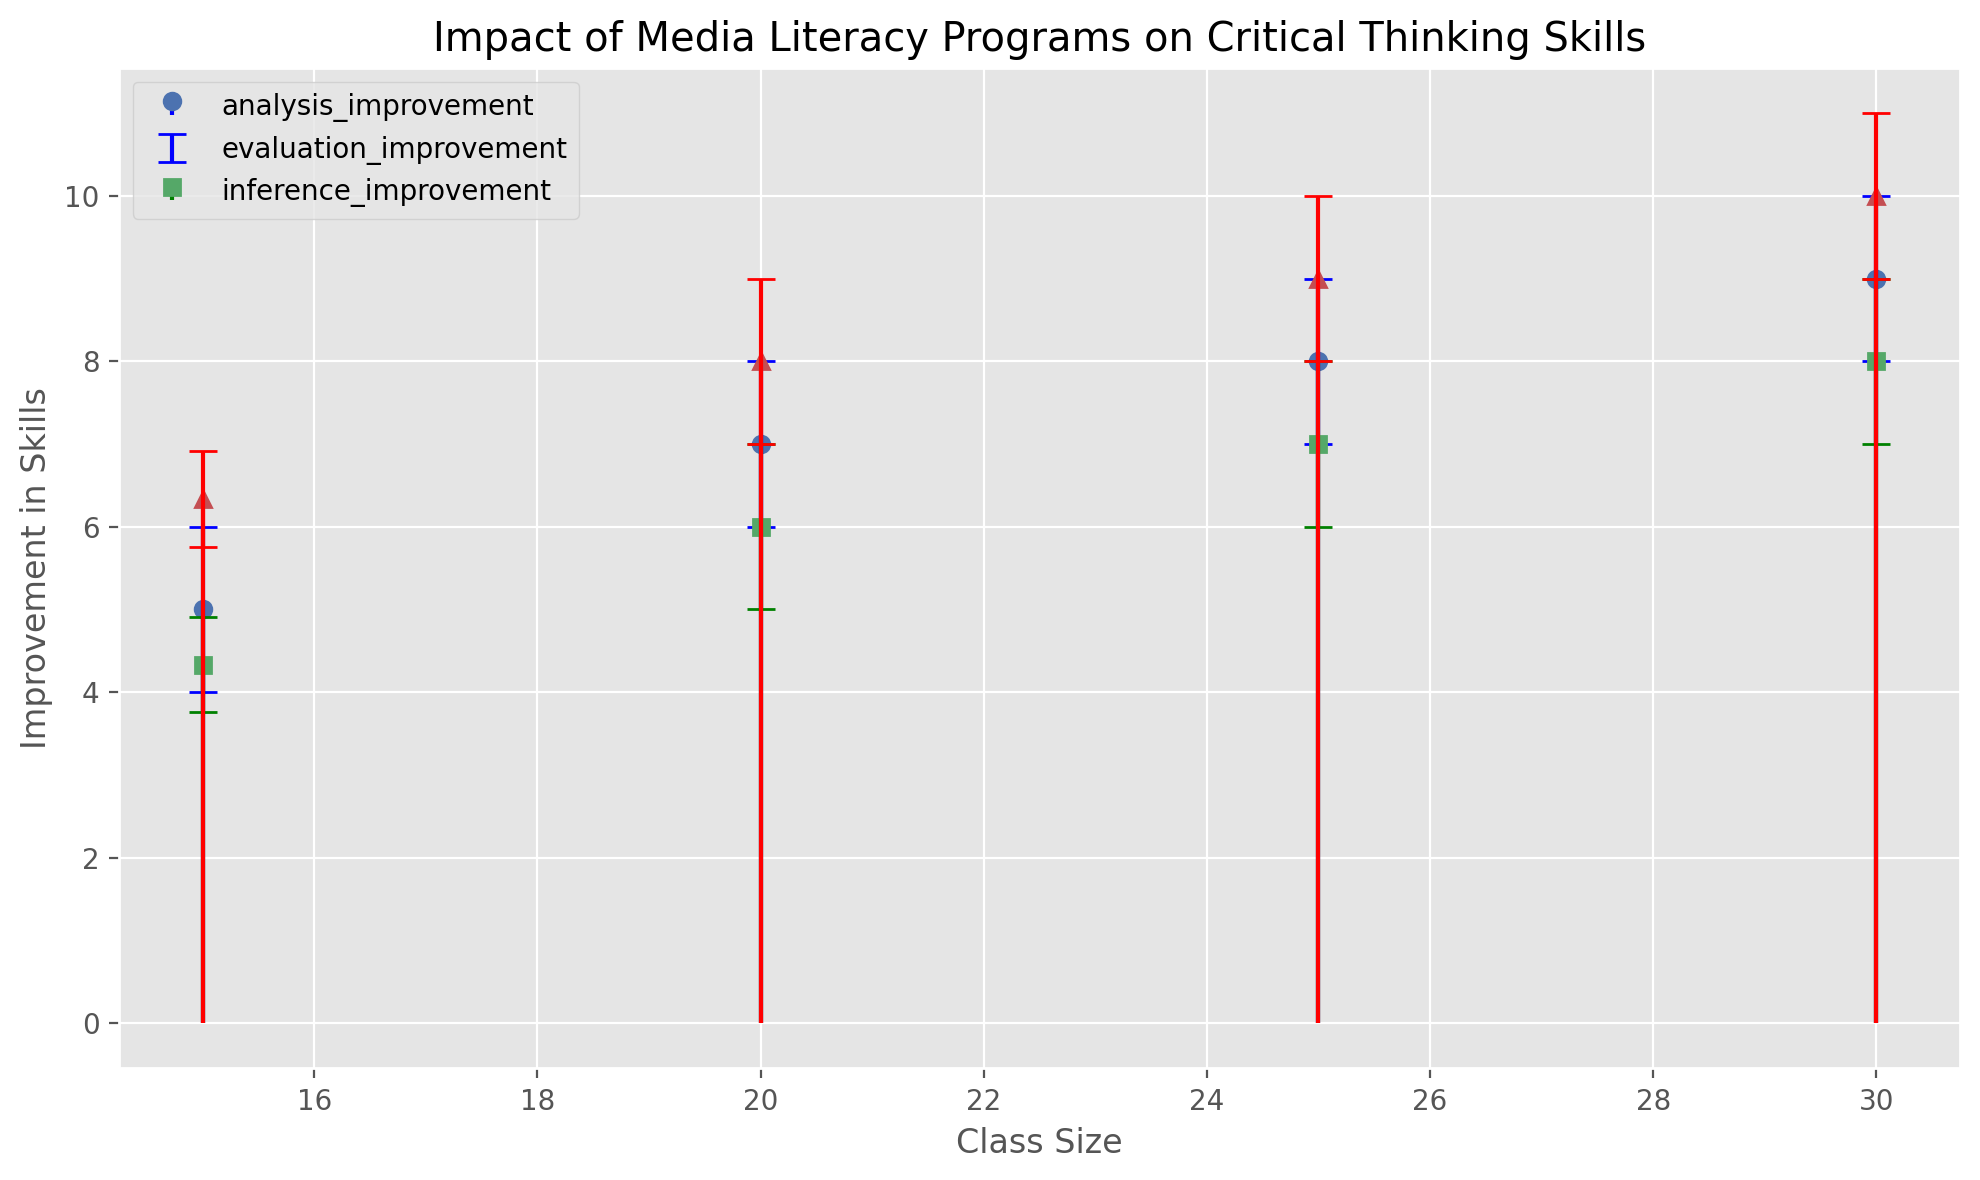What is the average improvement in analysis skills for a class size of 20? Sum the analysis improvement values (8 + 7 + 6) = 21. Divide by the number of data points (3). 21 / 3 = 7
Answer: 7 Which skill shows the highest average improvement for a class size of 30? Average improvement for analysis: (10 + 9 + 8) / 3 = 9. Average improvement for evaluation: (9 + 8 + 7) / 3 = 8. Average improvement for inference: (11 + 10 + 9) / 3 = 10. Compare these values.
Answer: Inference How does the average improvement in evaluation skills compare between class sizes of 15 and 25? Calculate the average improvement for both class sizes. For 15: (4 + 5 + 4) / 3 = 4.33. For 25: (8 + 7 + 6) / 3 = 7. Compare these averages.
Answer: 4.33 vs 7 What is the trend in average analysis improvement as class size increases from 15 to 30? Calculate the average improvement for each class size. For 15: (5 + 6 + 4) / 3 = 5. For 20: (8 + 7 + 6) / 3 = 7. For 25: (9 + 8 + 7) / 3 = 8. For 30: (10 + 9 + 8) / 3 = 9. Analyze the trend.
Answer: Increases Which class size exhibits the largest standard deviation in inference improvement? Observe the error bars for inference improvement. Identify which class size has the longest error bar.
Answer: 30 